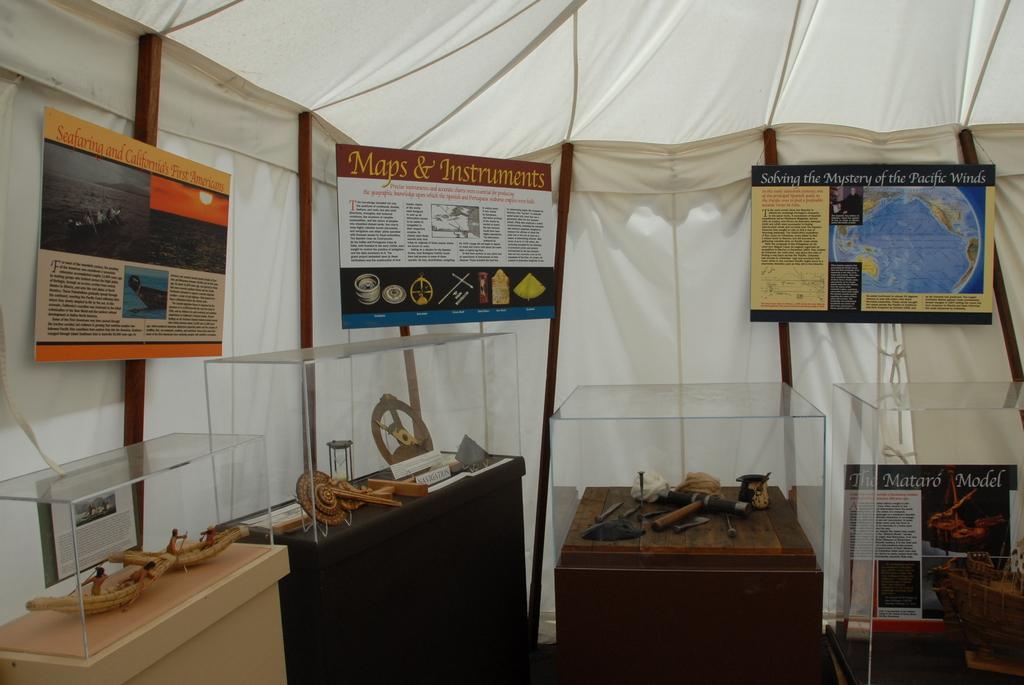Please provide a concise description of this image. In this picture I can observe some objects placed in the glass boxes. These glass boxes are placed on the desks which are in brown black and cream colors. I can observe some boards. There is some text on these boards. In this picture there is a white color fabric tent. 